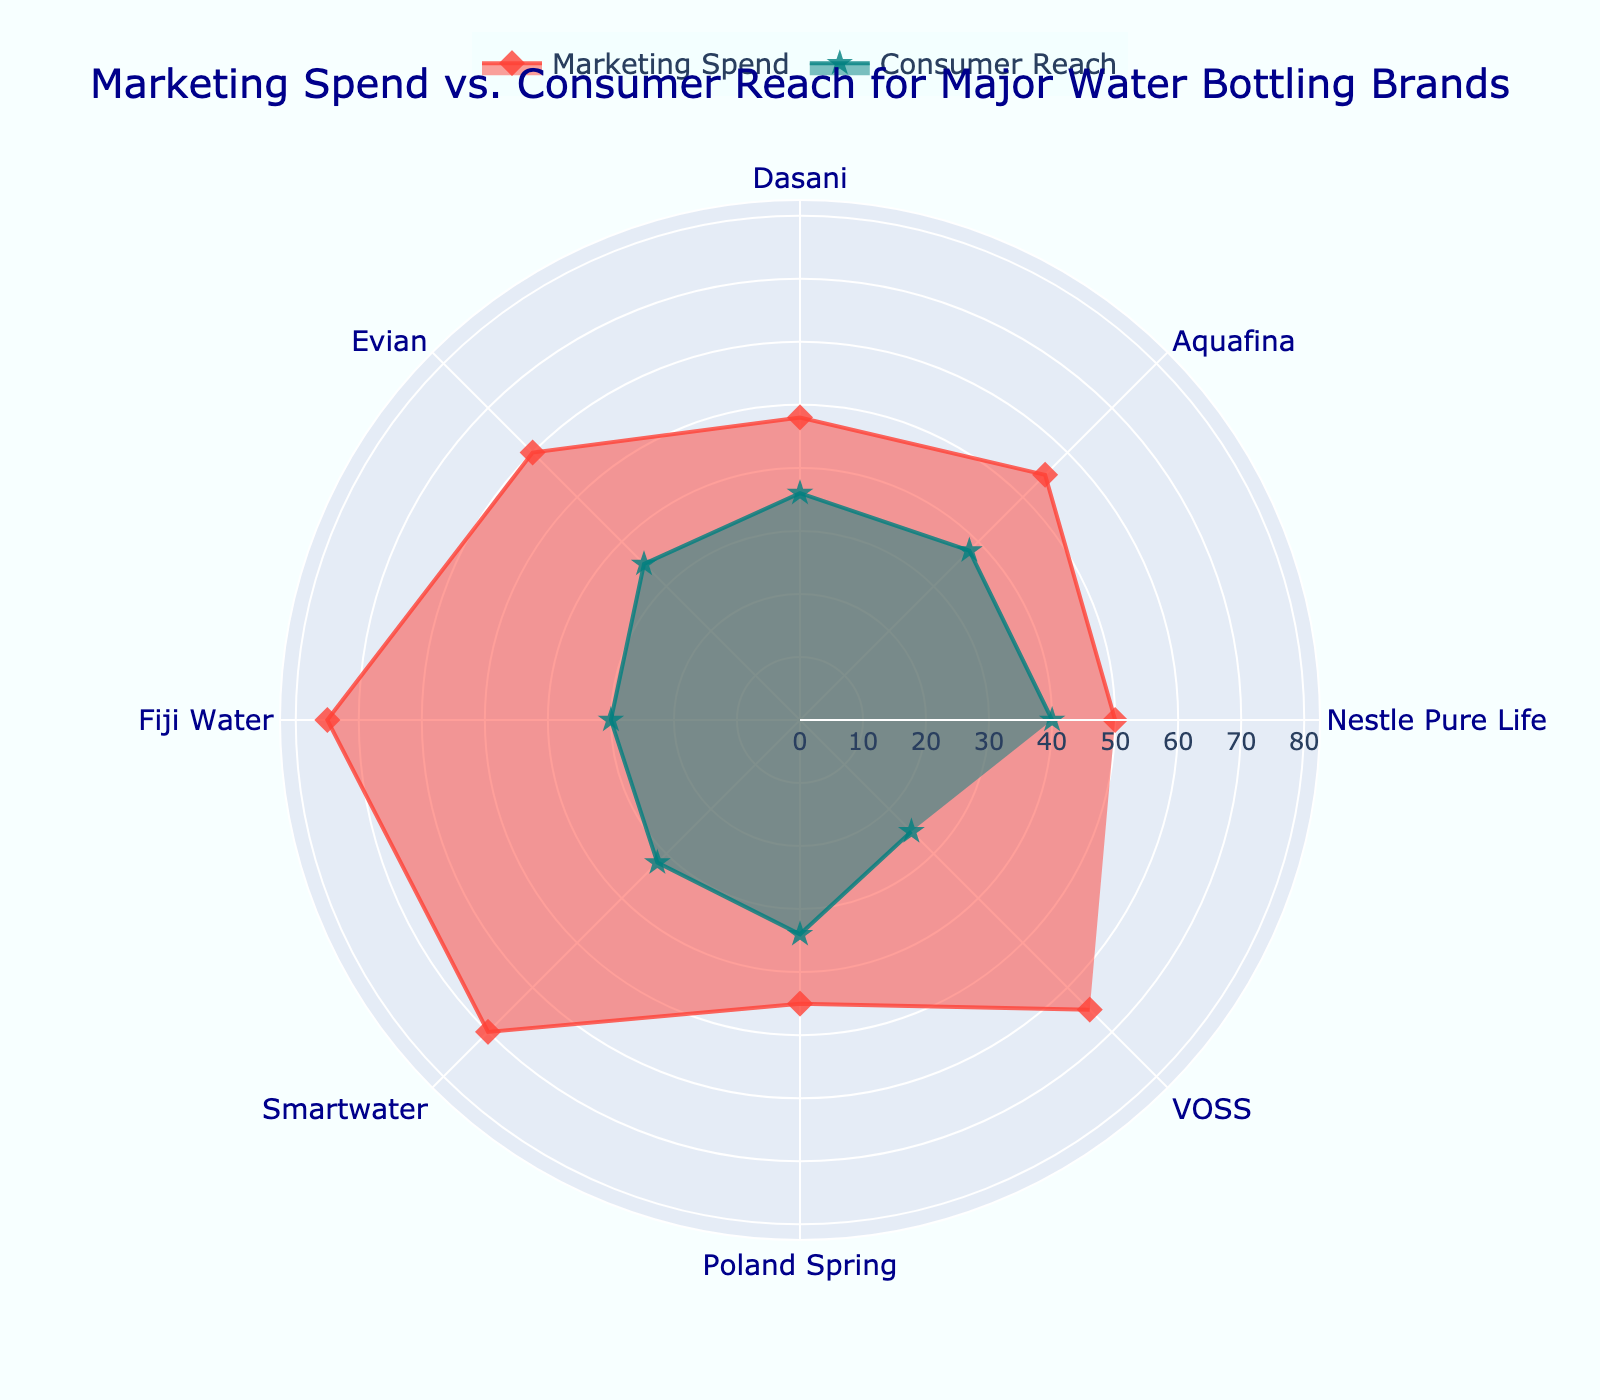What is the highest marketing spend among the brands? To find the highest marketing spend, look at the "Marketing Spend" radar plot and identify the maximum value.
Answer: 75 million USD Which brand has the lowest consumer reach? Check the "Consumer Reach" radar plot and find the brand with the minimum value.
Answer: VOSS How many brands are analyzed in this radar chart? The radar chart displays data points for each brand, count the unique segments.
Answer: 8 Which brand has a higher consumer reach, Fiji Water or Evian? Compare the "Consumer Reach" values for Fiji Water and Evian in the radar plot.
Answer: Evian What is the difference in marketing spend between Smartwater and Poland Spring? Subtract Poland Spring's marketing spend from Smartwater's marketing spend. Calculation: 70 - 45
Answer: 25 million USD What is the average consumer reach for Dasani, Aquafina, and Poland Spring? Add the consumer reach values for Dasani, Aquafina, and Poland Spring, then divide by 3. Calculation: (36 + 38 + 34) / 3
Answer: 36 million people Which brand has the larger marketing spend, Aquafina or VOSS? Compare the "Marketing Spend" values for Aquafina and VOSS in the radar plot.
Answer: VOSS Does Nestle Pure Life have a greater consumer reach than Smartwater? Compare the consumer reach values for Nestle Pure Life and Smartwater in the radar plot.
Answer: Yes Which two brands have the closest marketing spends? Identify the brands with the most similar values on the "Marketing Spend" radar plot.
Answer: Nestle Pure Life and Dasani What is the sum of consumer reach for all the brands? Add the consumer reach values for all the brands shown in the radar plot. Calculation: 40 + 38 + 36 + 35 + 30 + 32 + 34 + 25
Answer: 270 million people 